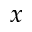<formula> <loc_0><loc_0><loc_500><loc_500>x</formula> 